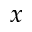<formula> <loc_0><loc_0><loc_500><loc_500>x</formula> 